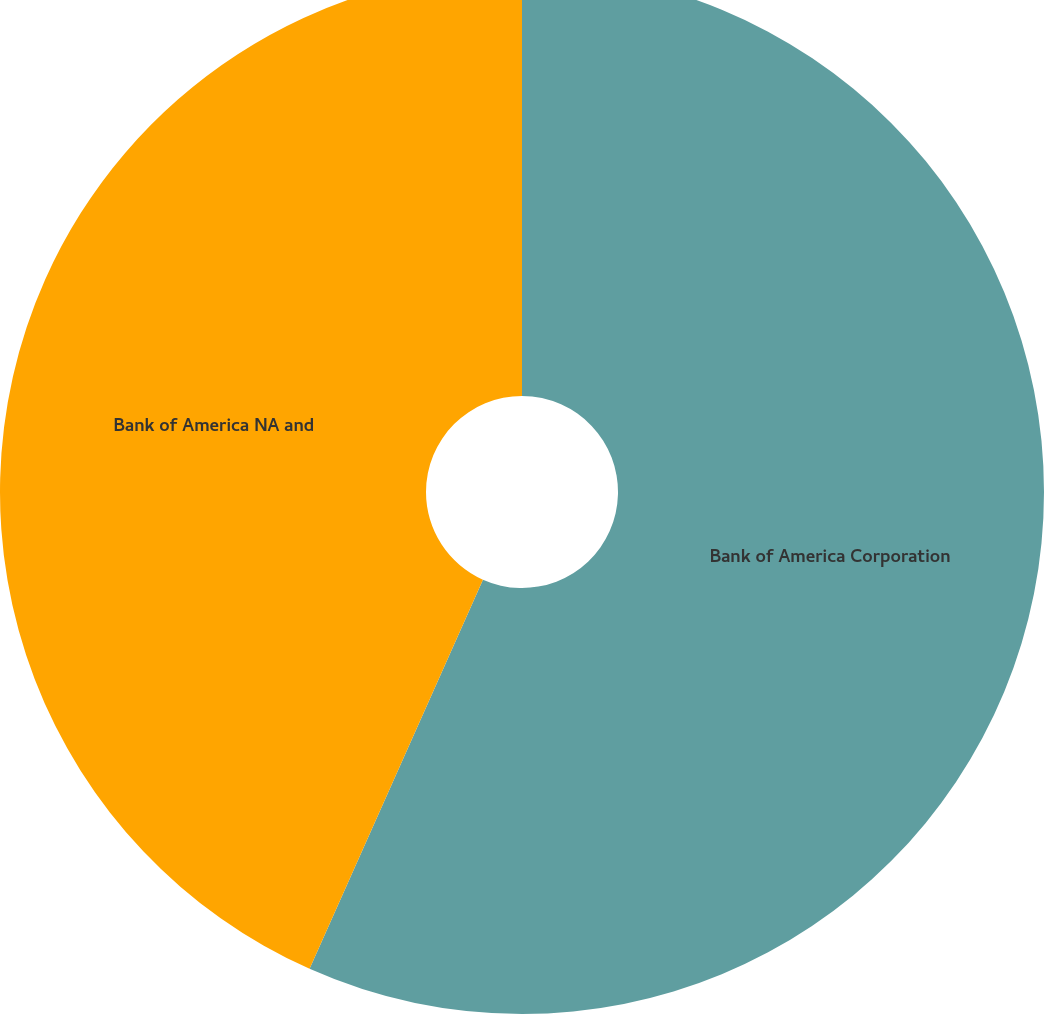Convert chart. <chart><loc_0><loc_0><loc_500><loc_500><pie_chart><fcel>Bank of America Corporation<fcel>Bank of America NA and<nl><fcel>56.67%<fcel>43.33%<nl></chart> 